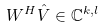<formula> <loc_0><loc_0><loc_500><loc_500>W ^ { H } \hat { V } \in \mathbb { C } ^ { k , l }</formula> 